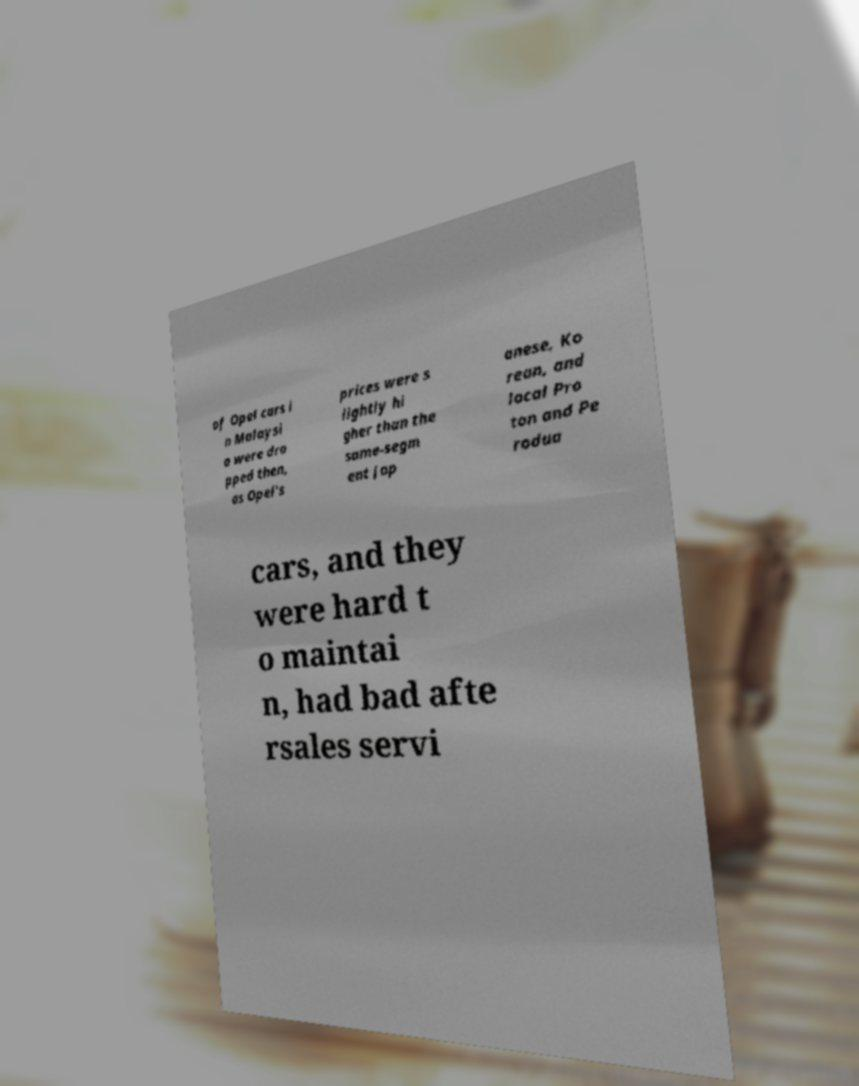Please identify and transcribe the text found in this image. of Opel cars i n Malaysi a were dro pped then, as Opel's prices were s lightly hi gher than the same-segm ent Jap anese, Ko rean, and local Pro ton and Pe rodua cars, and they were hard t o maintai n, had bad afte rsales servi 